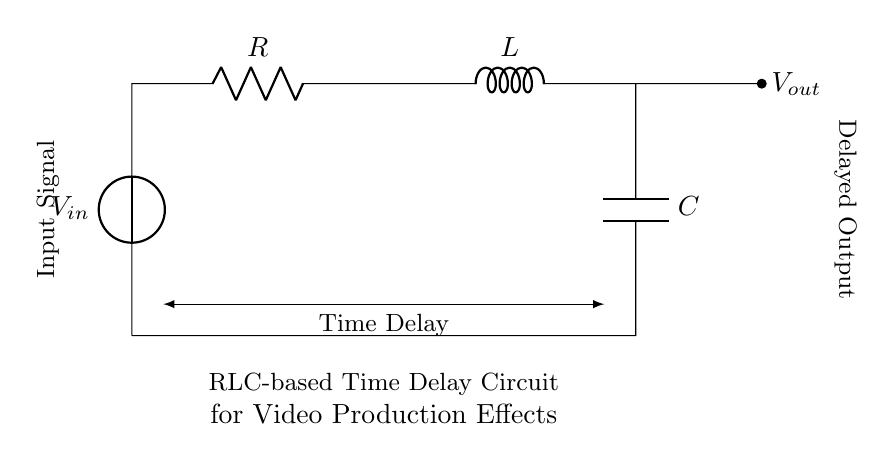What is the input voltage of the circuit? The input voltage is labeled as V_in on the schematic, indicating the voltage supplied to the circuit.
Answer: V_in What type of components are used in this circuit? The circuit includes a resistor, inductor, and capacitor, which are indicated by their respective symbols in the diagram.
Answer: Resistor, inductor, capacitor What is the purpose of the RLC components in this circuit? The RLC components together create a time delay effect that can be used for special effects in video production, as suggested by the title below the circuit.
Answer: Time delay for special effects How many components are in series in the circuit? The resistor, inductor, and capacitor are connected in series, so there are three components connected in this way.
Answer: Three What is the function of the capacitor in this circuit? The capacitor stores charge and affects the timing characteristics of the circuit, contributing to the delay in output signal production.
Answer: Stores charge, affects timing What happens to the output voltage when the time delay increases? As the time delay increases, the output voltage will change more gradually, indicating a slower response to the input signal.
Answer: Slower response to input What is indicated by the short arrow from the inductor to the output? The short arrow indicates a connection point where the output voltage V_out is taken from, providing the delayed signal to the next stage of processing.
Answer: Connection point for output voltage 